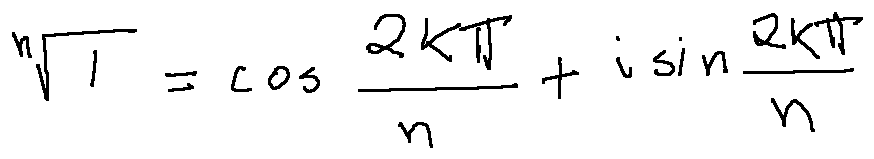Convert formula to latex. <formula><loc_0><loc_0><loc_500><loc_500>\sqrt { [ } n ] { 1 } = \cos \frac { 2 k \pi } { n } + i \sin \frac { 2 k \pi } { n }</formula> 